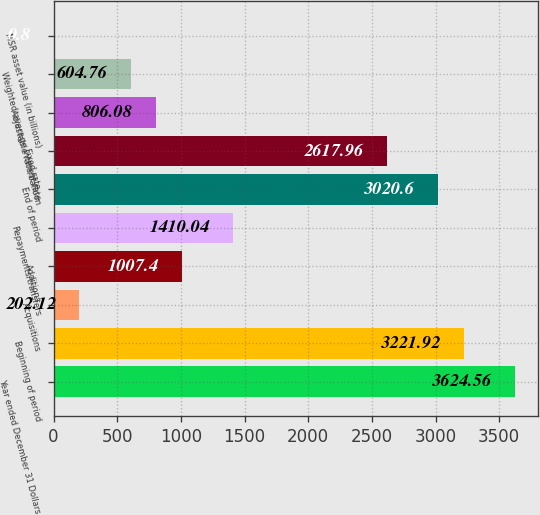<chart> <loc_0><loc_0><loc_500><loc_500><bar_chart><fcel>Year ended December 31 Dollars<fcel>Beginning of period<fcel>Acquisitions<fcel>Additions<fcel>Repayments/transfers<fcel>End of period<fcel>Fixed rate<fcel>Adjustable rate/balloon<fcel>Weighted-average interest rate<fcel>MSR asset value (in billions)<nl><fcel>3624.56<fcel>3221.92<fcel>202.12<fcel>1007.4<fcel>1410.04<fcel>3020.6<fcel>2617.96<fcel>806.08<fcel>604.76<fcel>0.8<nl></chart> 